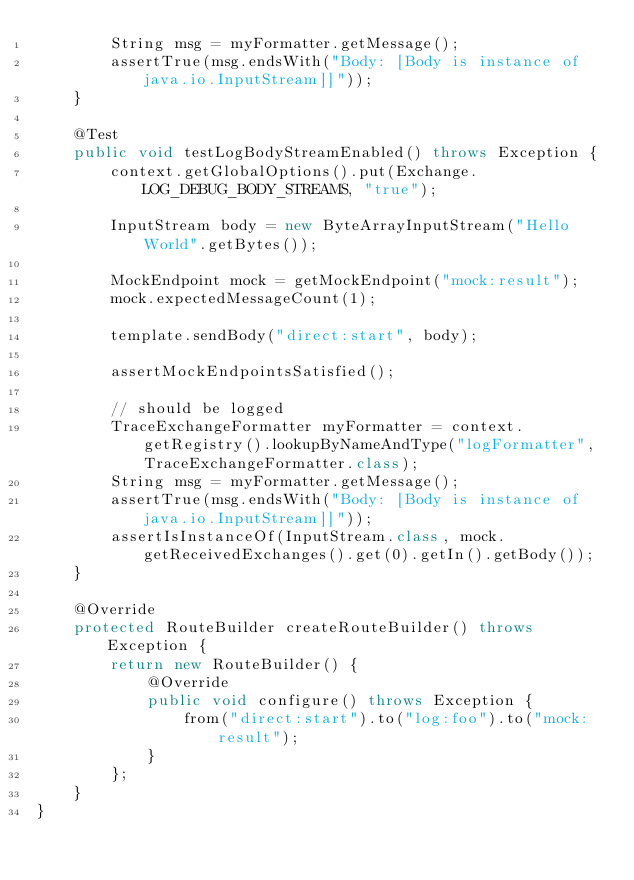<code> <loc_0><loc_0><loc_500><loc_500><_Java_>        String msg = myFormatter.getMessage();
        assertTrue(msg.endsWith("Body: [Body is instance of java.io.InputStream]]"));
    }

    @Test
    public void testLogBodyStreamEnabled() throws Exception {
        context.getGlobalOptions().put(Exchange.LOG_DEBUG_BODY_STREAMS, "true");

        InputStream body = new ByteArrayInputStream("Hello World".getBytes());

        MockEndpoint mock = getMockEndpoint("mock:result");
        mock.expectedMessageCount(1);

        template.sendBody("direct:start", body);

        assertMockEndpointsSatisfied();

        // should be logged
        TraceExchangeFormatter myFormatter = context.getRegistry().lookupByNameAndType("logFormatter", TraceExchangeFormatter.class);
        String msg = myFormatter.getMessage();
        assertTrue(msg.endsWith("Body: [Body is instance of java.io.InputStream]]"));
        assertIsInstanceOf(InputStream.class, mock.getReceivedExchanges().get(0).getIn().getBody());
    }

    @Override
    protected RouteBuilder createRouteBuilder() throws Exception {
        return new RouteBuilder() {
            @Override
            public void configure() throws Exception {
                from("direct:start").to("log:foo").to("mock:result");
            }
        };
    }
}
</code> 